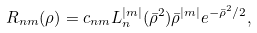Convert formula to latex. <formula><loc_0><loc_0><loc_500><loc_500>R _ { n m } ( \rho ) = c _ { n m } L _ { n } ^ { | m | } ( \bar { \rho } ^ { 2 } ) \bar { \rho } ^ { | m | } e ^ { - \bar { \rho } ^ { 2 } / 2 } ,</formula> 